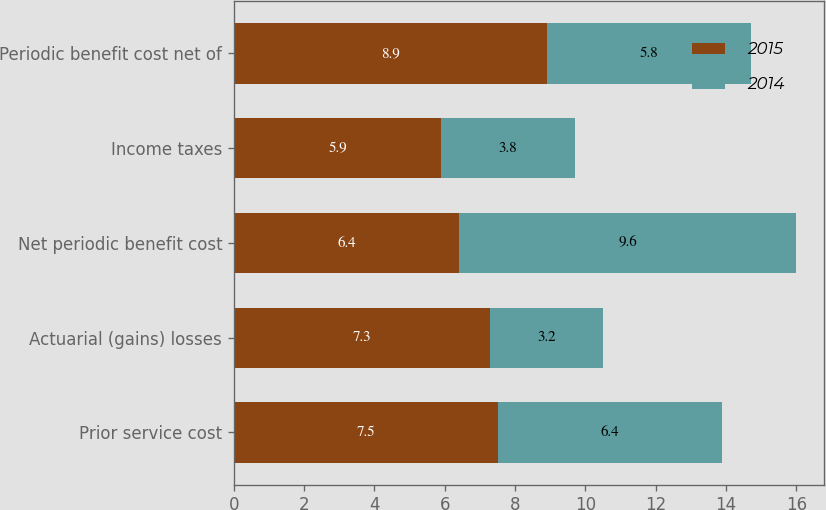Convert chart. <chart><loc_0><loc_0><loc_500><loc_500><stacked_bar_chart><ecel><fcel>Prior service cost<fcel>Actuarial (gains) losses<fcel>Net periodic benefit cost<fcel>Income taxes<fcel>Periodic benefit cost net of<nl><fcel>2015<fcel>7.5<fcel>7.3<fcel>6.4<fcel>5.9<fcel>8.9<nl><fcel>2014<fcel>6.4<fcel>3.2<fcel>9.6<fcel>3.8<fcel>5.8<nl></chart> 